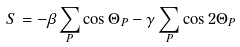Convert formula to latex. <formula><loc_0><loc_0><loc_500><loc_500>S = - \beta \sum _ { P } \cos \Theta _ { P } - \gamma \sum _ { P } \cos 2 \Theta _ { P }</formula> 